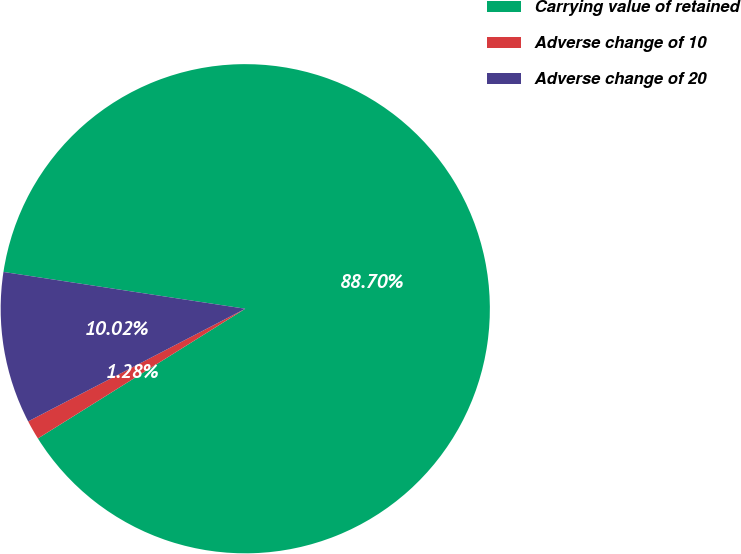Convert chart. <chart><loc_0><loc_0><loc_500><loc_500><pie_chart><fcel>Carrying value of retained<fcel>Adverse change of 10<fcel>Adverse change of 20<nl><fcel>88.7%<fcel>1.28%<fcel>10.02%<nl></chart> 